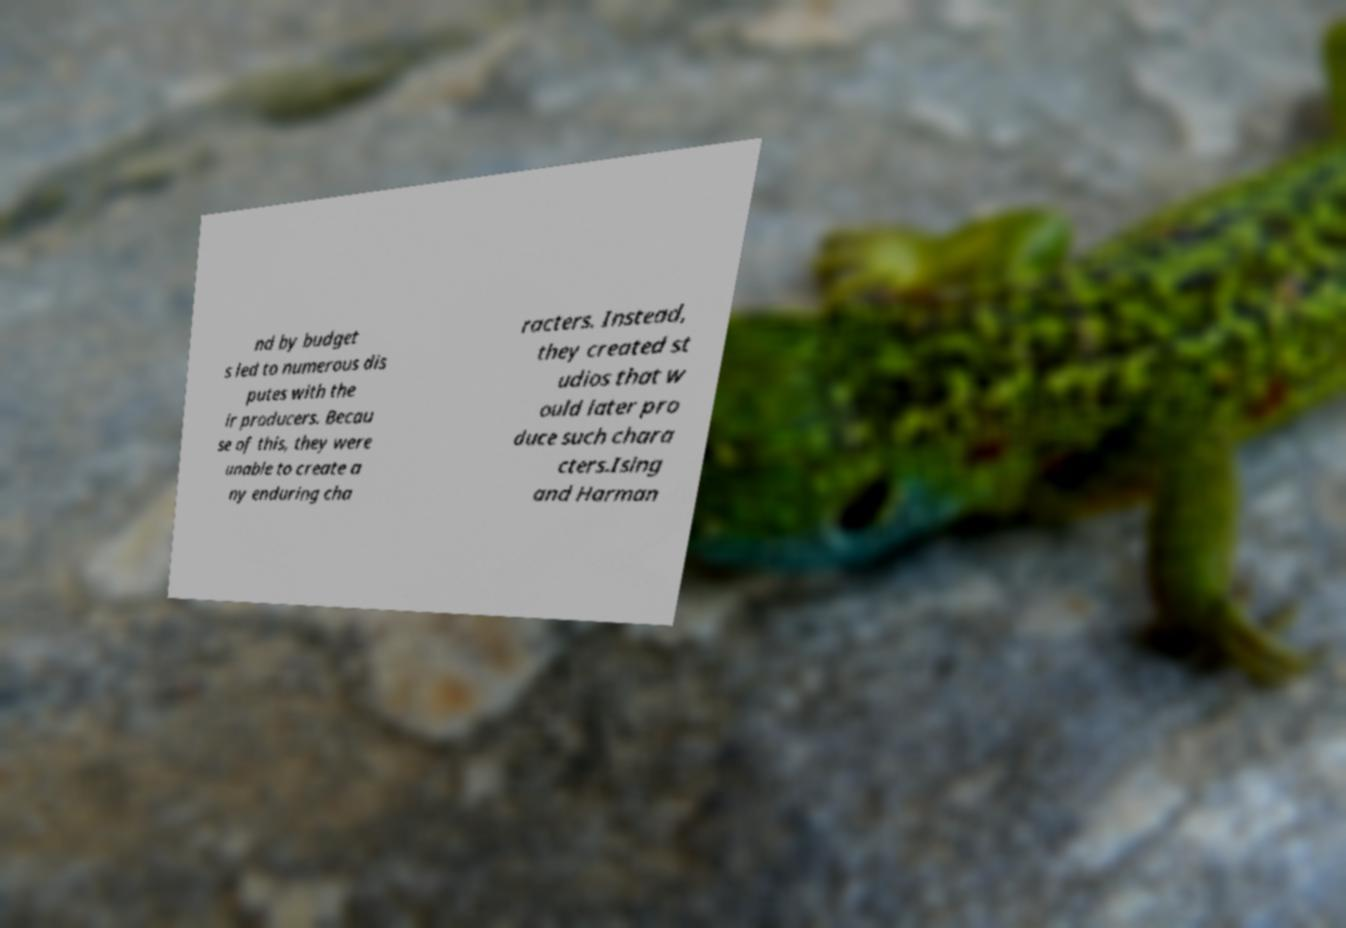Could you extract and type out the text from this image? nd by budget s led to numerous dis putes with the ir producers. Becau se of this, they were unable to create a ny enduring cha racters. Instead, they created st udios that w ould later pro duce such chara cters.Ising and Harman 